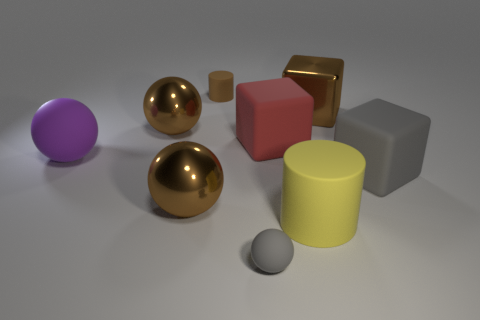Subtract all big brown shiny blocks. How many blocks are left? 2 Subtract all cyan cylinders. How many brown balls are left? 2 Subtract 1 balls. How many balls are left? 3 Subtract all gray balls. How many balls are left? 3 Subtract all purple balls. Subtract all cyan cubes. How many balls are left? 3 Subtract all cubes. How many objects are left? 6 Add 7 small brown cylinders. How many small brown cylinders exist? 8 Subtract 1 brown cylinders. How many objects are left? 8 Subtract all big red rubber things. Subtract all big brown balls. How many objects are left? 6 Add 4 gray spheres. How many gray spheres are left? 5 